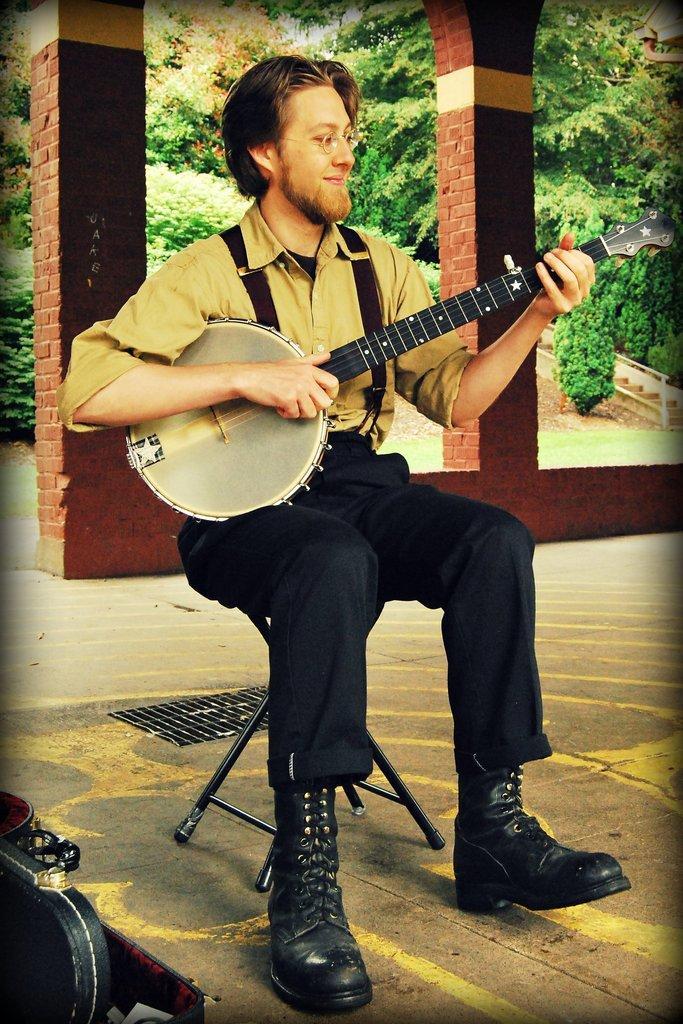In one or two sentences, can you explain what this image depicts? There is man sitting in the middle of the image. He is playing one musical instrument. He is wearing yellow shirt and black pant with black boots. Behind him there are two pillars. In the background there are trees. The man is smiling. 